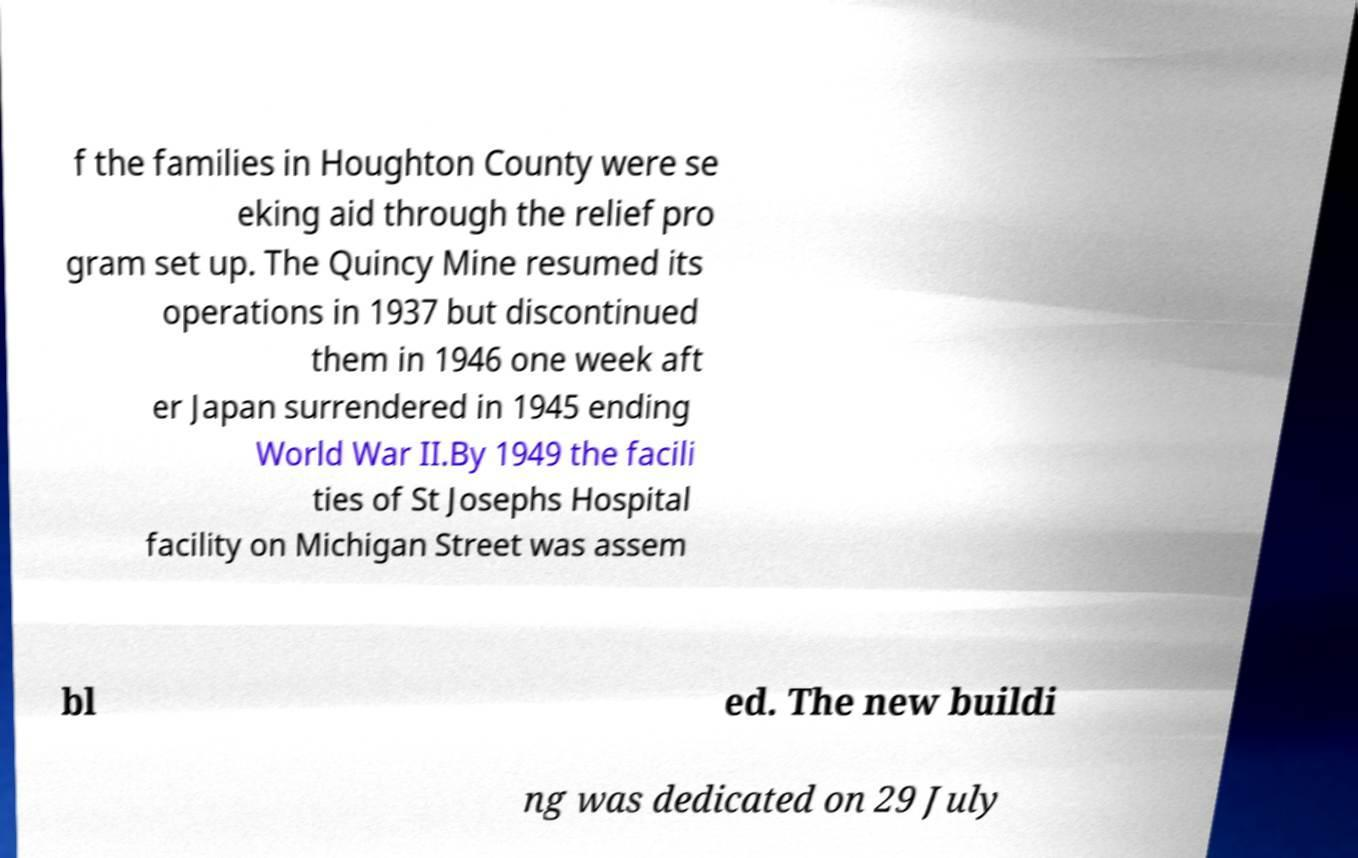Please read and relay the text visible in this image. What does it say? f the families in Houghton County were se eking aid through the relief pro gram set up. The Quincy Mine resumed its operations in 1937 but discontinued them in 1946 one week aft er Japan surrendered in 1945 ending World War II.By 1949 the facili ties of St Josephs Hospital facility on Michigan Street was assem bl ed. The new buildi ng was dedicated on 29 July 